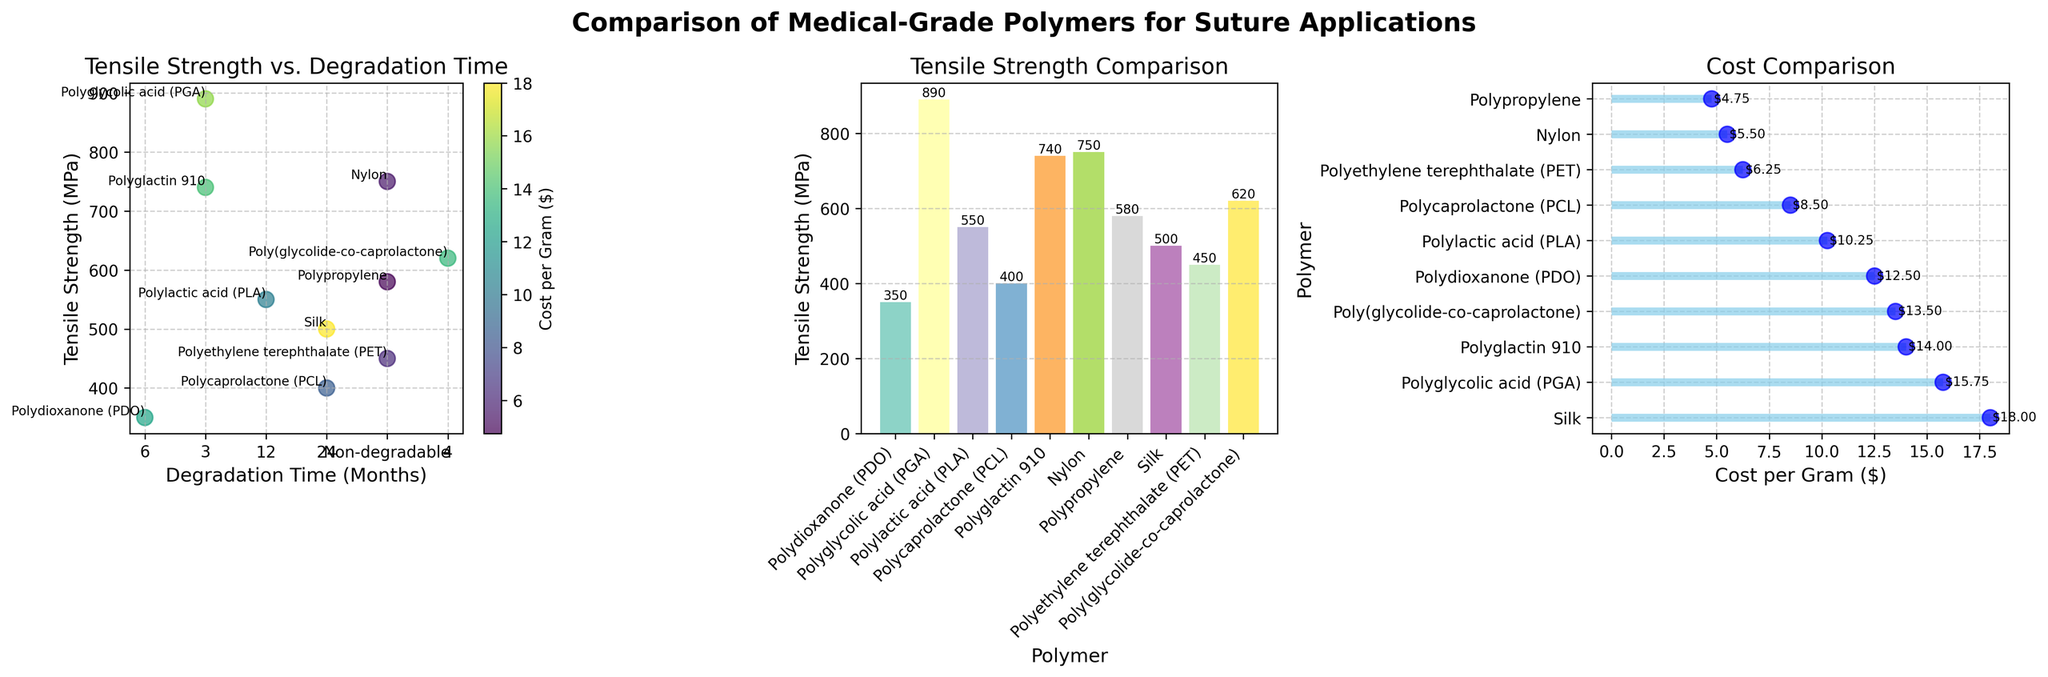What is the tensile strength of Polydioxanone (PDO)? Look at the bar labeled "Polydioxanone (PDO)" in the tensile strength comparison plot. It reaches up to the value on the y-axis which is approximately 350 MPa.
Answer: 350 MPa Which polymer has the highest tensile strength? In the tensile strength comparison subplot, compare the height of the bars to find the tallest one. The "Polyglycolic acid (PGA)" bar reaches the highest value on the y-axis, close to 890 MPa.
Answer: Polyglycolic acid (PGA) How does the tensile strength of Polypropylene compare to Silk? Check the height of the bars labeled "Polypropylene" and "Silk" in the tensile strength comparison subplot. "Polypropylene" has a tensile strength of around 580 MPa, while "Silk" has a tensile strength of approximately 500 MPa. Polypropylene is therefore higher than Silk.
Answer: Polypropylene is higher What is the relationship between "Tensile Strength (MPa)" and "Degradation Time" for polymers? Observe the scatter plot of tensile strength vs. degradation time. Most degradable polymers exhibit a range of tensile strengths, and there is no clear linear relationship; however, degradable polymers like PGA and Polyglactin 910 have higher tensile strengths but shorter degradation times. Non-degradable polymers (shown at rightmost points) do not follow this trend.
Answer: Varied, no clear linear relationship Which polymer costs the most per gram? Look at the cost comparison plot and find the highest point on the x-axis, which represents the cost. The polymer at this point is "Silk" with around $18.00 per gram.
Answer: Silk What is the trade-off between the cost per gram and tensile strength of polymers? Observe the scatter and bar plots where cost per gram is indicated by color shading in the scatter plot and by labels in the cost comparison plot. Generally, higher tensile strength such as PGA (~890 MPa) coincides with higher costs, but exceptions exist such as Nylon which has a high tensile strength but a lower cost. There is a notable trade-off; higher tensile strength can come with higher costs, but not always.
Answer: Higher tensile strength often incurs higher costs, but exceptions exist Between Polylactic acid (PLA) and Polycaprolactone (PCL), which one degrades faster? On the scatter plot of tensile strength vs. degradation time, locate the points for PLA and PCL. PLA has a degradation time of 12 months, while PCL has a degradation time of 24 months. Therefore, PLA degrades faster.
Answer: PLA Based on the scatter plot, what is the tensor strength of the lowest cost polymer? Look for the cost legend on the scatter plot and find the polymer with the lowest cost (color-coded for lowest value). The lowest cost polymer is Polypropylene (~$4.75 per gram) with tensile strength of around 580 MPa.
Answer: 580 MPa Which polymer has the longest degradation time with a tensile strength above 500 MPa? In the scatter plot, locate polymers with degradation times labeled "24 months" and find tensile strength above 500 MPa. Polymers with these properties include Silk.
Answer: Silk 